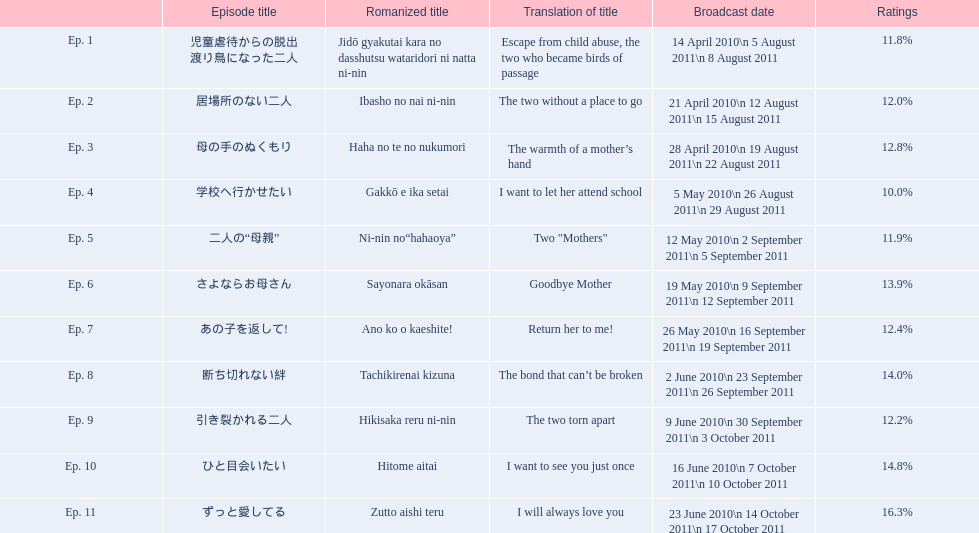Can you parse all the data within this table? {'header': ['', 'Episode title', 'Romanized title', 'Translation of title', 'Broadcast date', 'Ratings'], 'rows': [['Ep. 1', '児童虐待からの脱出 渡り鳥になった二人', 'Jidō gyakutai kara no dasshutsu wataridori ni natta ni-nin', 'Escape from child abuse, the two who became birds of passage', '14 April 2010\\n 5 August 2011\\n 8 August 2011', '11.8%'], ['Ep. 2', '居場所のない二人', 'Ibasho no nai ni-nin', 'The two without a place to go', '21 April 2010\\n 12 August 2011\\n 15 August 2011', '12.0%'], ['Ep. 3', '母の手のぬくもり', 'Haha no te no nukumori', 'The warmth of a mother’s hand', '28 April 2010\\n 19 August 2011\\n 22 August 2011', '12.8%'], ['Ep. 4', '学校へ行かせたい', 'Gakkō e ika setai', 'I want to let her attend school', '5 May 2010\\n 26 August 2011\\n 29 August 2011', '10.0%'], ['Ep. 5', '二人の“母親”', 'Ni-nin no“hahaoya”', 'Two "Mothers"', '12 May 2010\\n 2 September 2011\\n 5 September 2011', '11.9%'], ['Ep. 6', 'さよならお母さん', 'Sayonara okāsan', 'Goodbye Mother', '19 May 2010\\n 9 September 2011\\n 12 September 2011', '13.9%'], ['Ep. 7', 'あの子を返して!', 'Ano ko o kaeshite!', 'Return her to me!', '26 May 2010\\n 16 September 2011\\n 19 September 2011', '12.4%'], ['Ep. 8', '断ち切れない絆', 'Tachikirenai kizuna', 'The bond that can’t be broken', '2 June 2010\\n 23 September 2011\\n 26 September 2011', '14.0%'], ['Ep. 9', '引き裂かれる二人', 'Hikisaka reru ni-nin', 'The two torn apart', '9 June 2010\\n 30 September 2011\\n 3 October 2011', '12.2%'], ['Ep. 10', 'ひと目会いたい', 'Hitome aitai', 'I want to see you just once', '16 June 2010\\n 7 October 2011\\n 10 October 2011', '14.8%'], ['Ep. 11', 'ずっと愛してる', 'Zutto aishi teru', 'I will always love you', '23 June 2010\\n 14 October 2011\\n 17 October 2011', '16.3%']]} What is the designation of episode 8? 断ち切れない絆. What was the viewership for this particular episode? 14.0%. 